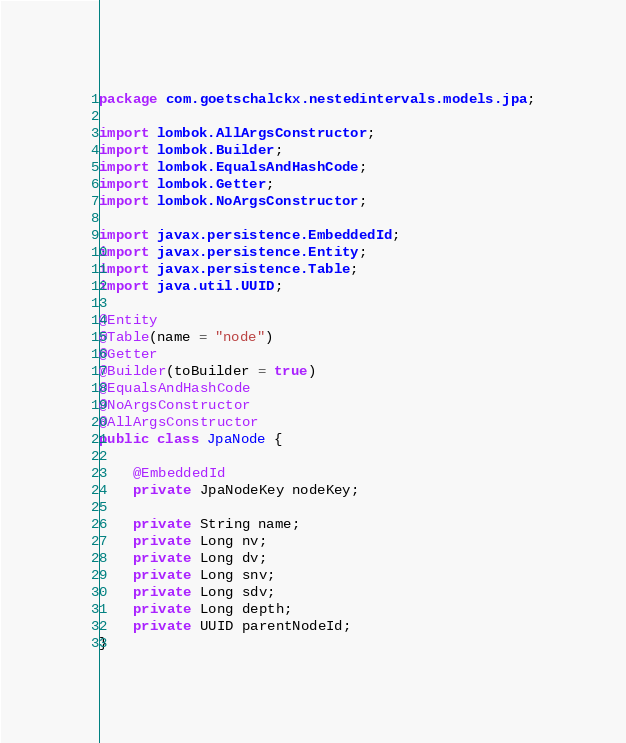<code> <loc_0><loc_0><loc_500><loc_500><_Java_>package com.goetschalckx.nestedintervals.models.jpa;

import lombok.AllArgsConstructor;
import lombok.Builder;
import lombok.EqualsAndHashCode;
import lombok.Getter;
import lombok.NoArgsConstructor;

import javax.persistence.EmbeddedId;
import javax.persistence.Entity;
import javax.persistence.Table;
import java.util.UUID;

@Entity
@Table(name = "node")
@Getter
@Builder(toBuilder = true)
@EqualsAndHashCode
@NoArgsConstructor
@AllArgsConstructor
public class JpaNode {

    @EmbeddedId
    private JpaNodeKey nodeKey;

    private String name;
    private Long nv;
    private Long dv;
    private Long snv;
    private Long sdv;
    private Long depth;
    private UUID parentNodeId;
}
</code> 